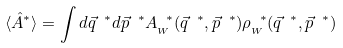<formula> <loc_0><loc_0><loc_500><loc_500>\langle \hat { A } ^ { * } \rangle = \int d \vec { q } ^ { \ * } d \vec { p } ^ { \ * } A _ { _ { W } } ^ { \ * } ( \vec { q } ^ { \ * } , \vec { p } ^ { \ * } ) \rho _ { _ { W } } ^ { \ * } ( \vec { q } ^ { \ * } , \vec { p } ^ { \ * } )</formula> 